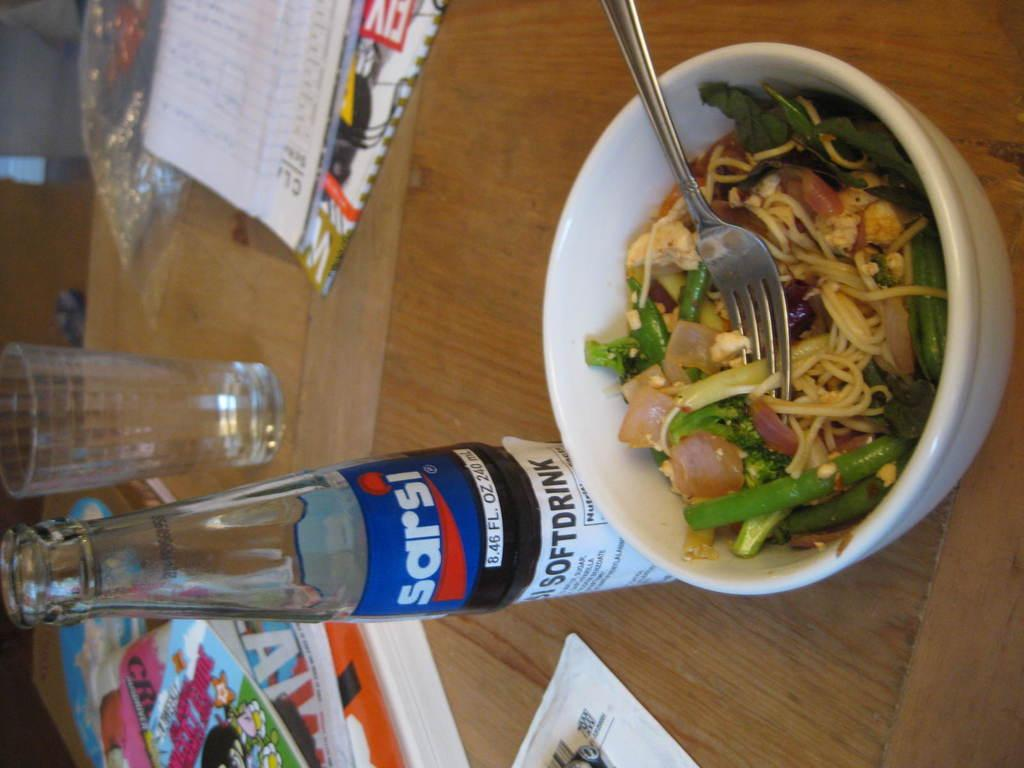<image>
Present a compact description of the photo's key features. A bowl with a salad and a half drunk glass bottle of sarsi cola. 